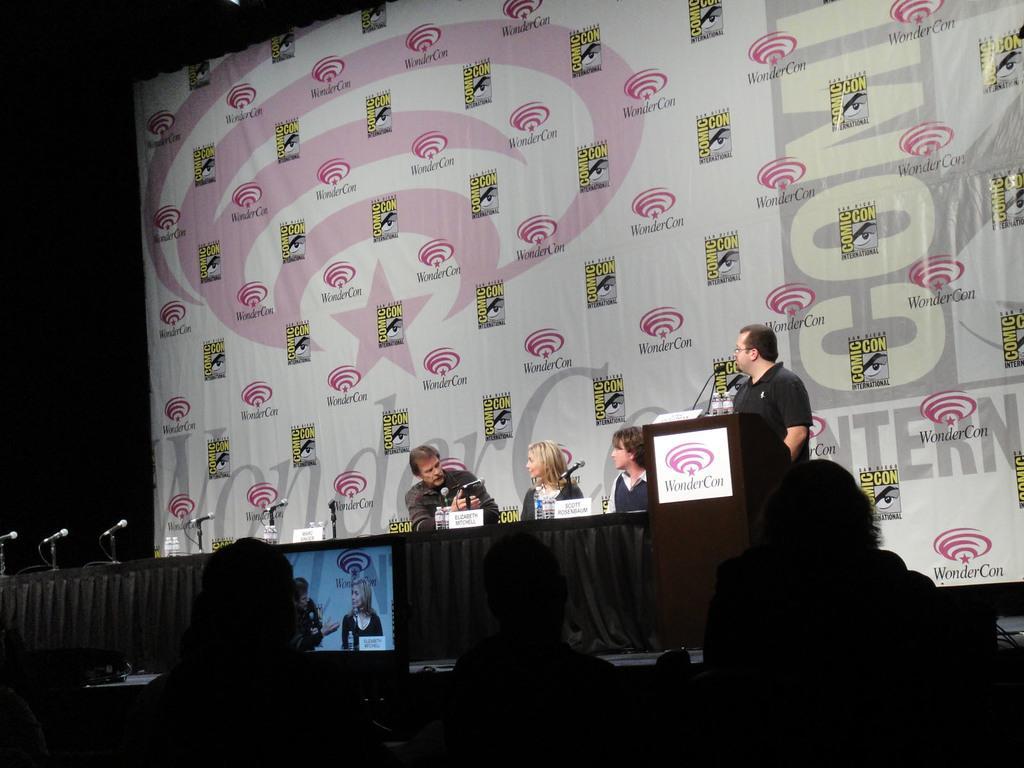In one or two sentences, can you explain what this image depicts? In this image there are people sitting on chairs, in front of them there is a stage, on that stage there is a table, on that table there is a cloth, mike's, boards and bottles, behind the table there are people sitting on chairs and a person standing near a podium, behind the persons there is a banner, on that banner there is some text. 